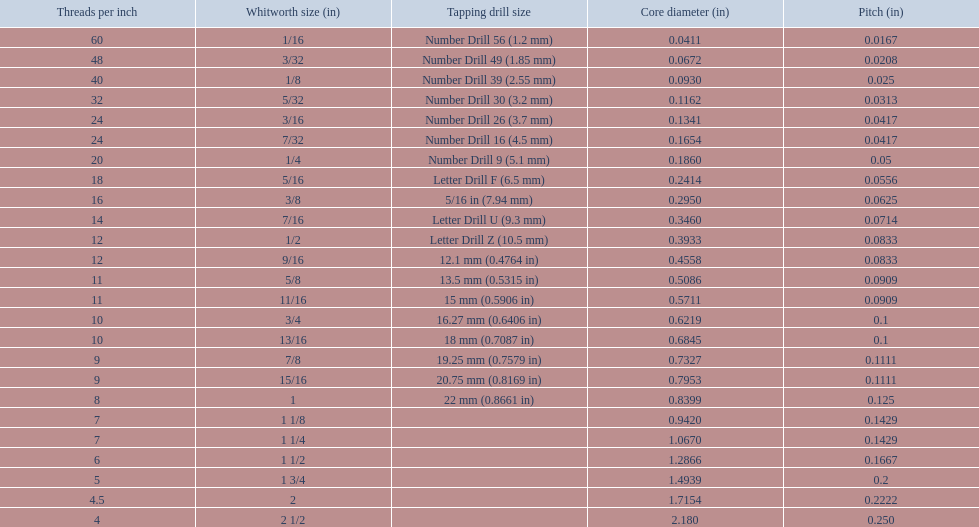What are the whitworth sizes? 1/16, 3/32, 1/8, 5/32, 3/16, 7/32, 1/4, 5/16, 3/8, 7/16, 1/2, 9/16, 5/8, 11/16, 3/4, 13/16, 7/8, 15/16, 1, 1 1/8, 1 1/4, 1 1/2, 1 3/4, 2, 2 1/2. And their threads per inch? 60, 48, 40, 32, 24, 24, 20, 18, 16, 14, 12, 12, 11, 11, 10, 10, 9, 9, 8, 7, 7, 6, 5, 4.5, 4. Now, which whitworth size has a thread-per-inch size of 5?? 1 3/4. 